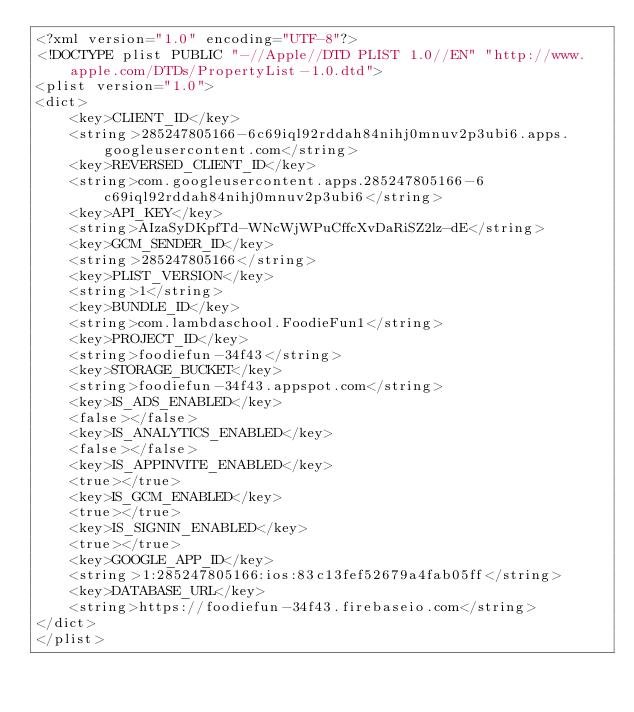Convert code to text. <code><loc_0><loc_0><loc_500><loc_500><_XML_><?xml version="1.0" encoding="UTF-8"?>
<!DOCTYPE plist PUBLIC "-//Apple//DTD PLIST 1.0//EN" "http://www.apple.com/DTDs/PropertyList-1.0.dtd">
<plist version="1.0">
<dict>
	<key>CLIENT_ID</key>
	<string>285247805166-6c69iql92rddah84nihj0mnuv2p3ubi6.apps.googleusercontent.com</string>
	<key>REVERSED_CLIENT_ID</key>
	<string>com.googleusercontent.apps.285247805166-6c69iql92rddah84nihj0mnuv2p3ubi6</string>
	<key>API_KEY</key>
	<string>AIzaSyDKpfTd-WNcWjWPuCffcXvDaRiSZ2lz-dE</string>
	<key>GCM_SENDER_ID</key>
	<string>285247805166</string>
	<key>PLIST_VERSION</key>
	<string>1</string>
	<key>BUNDLE_ID</key>
	<string>com.lambdaschool.FoodieFun1</string>
	<key>PROJECT_ID</key>
	<string>foodiefun-34f43</string>
	<key>STORAGE_BUCKET</key>
	<string>foodiefun-34f43.appspot.com</string>
	<key>IS_ADS_ENABLED</key>
	<false></false>
	<key>IS_ANALYTICS_ENABLED</key>
	<false></false>
	<key>IS_APPINVITE_ENABLED</key>
	<true></true>
	<key>IS_GCM_ENABLED</key>
	<true></true>
	<key>IS_SIGNIN_ENABLED</key>
	<true></true>
	<key>GOOGLE_APP_ID</key>
	<string>1:285247805166:ios:83c13fef52679a4fab05ff</string>
	<key>DATABASE_URL</key>
	<string>https://foodiefun-34f43.firebaseio.com</string>
</dict>
</plist></code> 